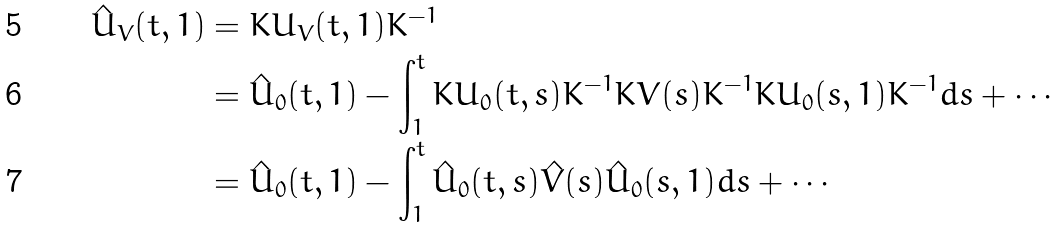Convert formula to latex. <formula><loc_0><loc_0><loc_500><loc_500>\hat { U } _ { V } ( t , 1 ) & = K U _ { V } ( t , 1 ) K ^ { - 1 } \\ & = \hat { U } _ { 0 } ( t , 1 ) - \int _ { 1 } ^ { t } K U _ { 0 } ( t , s ) K ^ { - 1 } K V ( s ) K ^ { - 1 } K U _ { 0 } ( s , 1 ) K ^ { - 1 } d s + \cdots \\ & = \hat { U } _ { 0 } ( t , 1 ) - \int _ { 1 } ^ { t } \hat { U } _ { 0 } ( t , s ) \hat { V } ( s ) \hat { U } _ { 0 } ( s , 1 ) d s + \cdots</formula> 